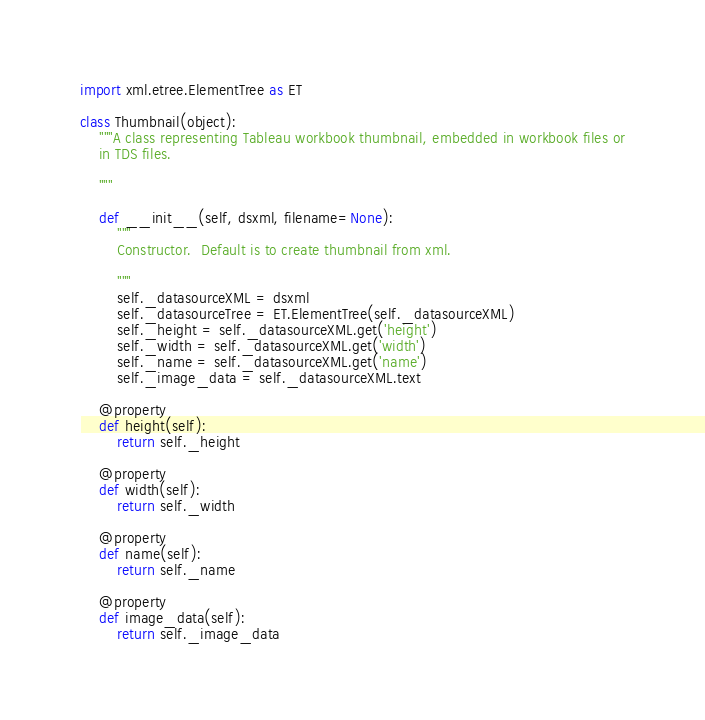Convert code to text. <code><loc_0><loc_0><loc_500><loc_500><_Python_>import xml.etree.ElementTree as ET

class Thumbnail(object):
    """A class representing Tableau workbook thumbnail, embedded in workbook files or
    in TDS files.

    """

    def __init__(self, dsxml, filename=None):
        """
        Constructor.  Default is to create thumbnail from xml.

        """
        self._datasourceXML = dsxml
        self._datasourceTree = ET.ElementTree(self._datasourceXML)
        self._height = self._datasourceXML.get('height')
        self._width = self._datasourceXML.get('width')
        self._name = self._datasourceXML.get('name')
        self._image_data = self._datasourceXML.text

    @property
    def height(self):
        return self._height

    @property
    def width(self):
        return self._width

    @property
    def name(self):
        return self._name

    @property
    def image_data(self):
        return self._image_data        
</code> 